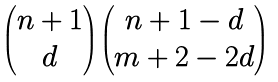<formula> <loc_0><loc_0><loc_500><loc_500>\begin{pmatrix} n + 1 \\ d \end{pmatrix} \begin{pmatrix} n + 1 - d \\ m + 2 - 2 d \end{pmatrix}</formula> 